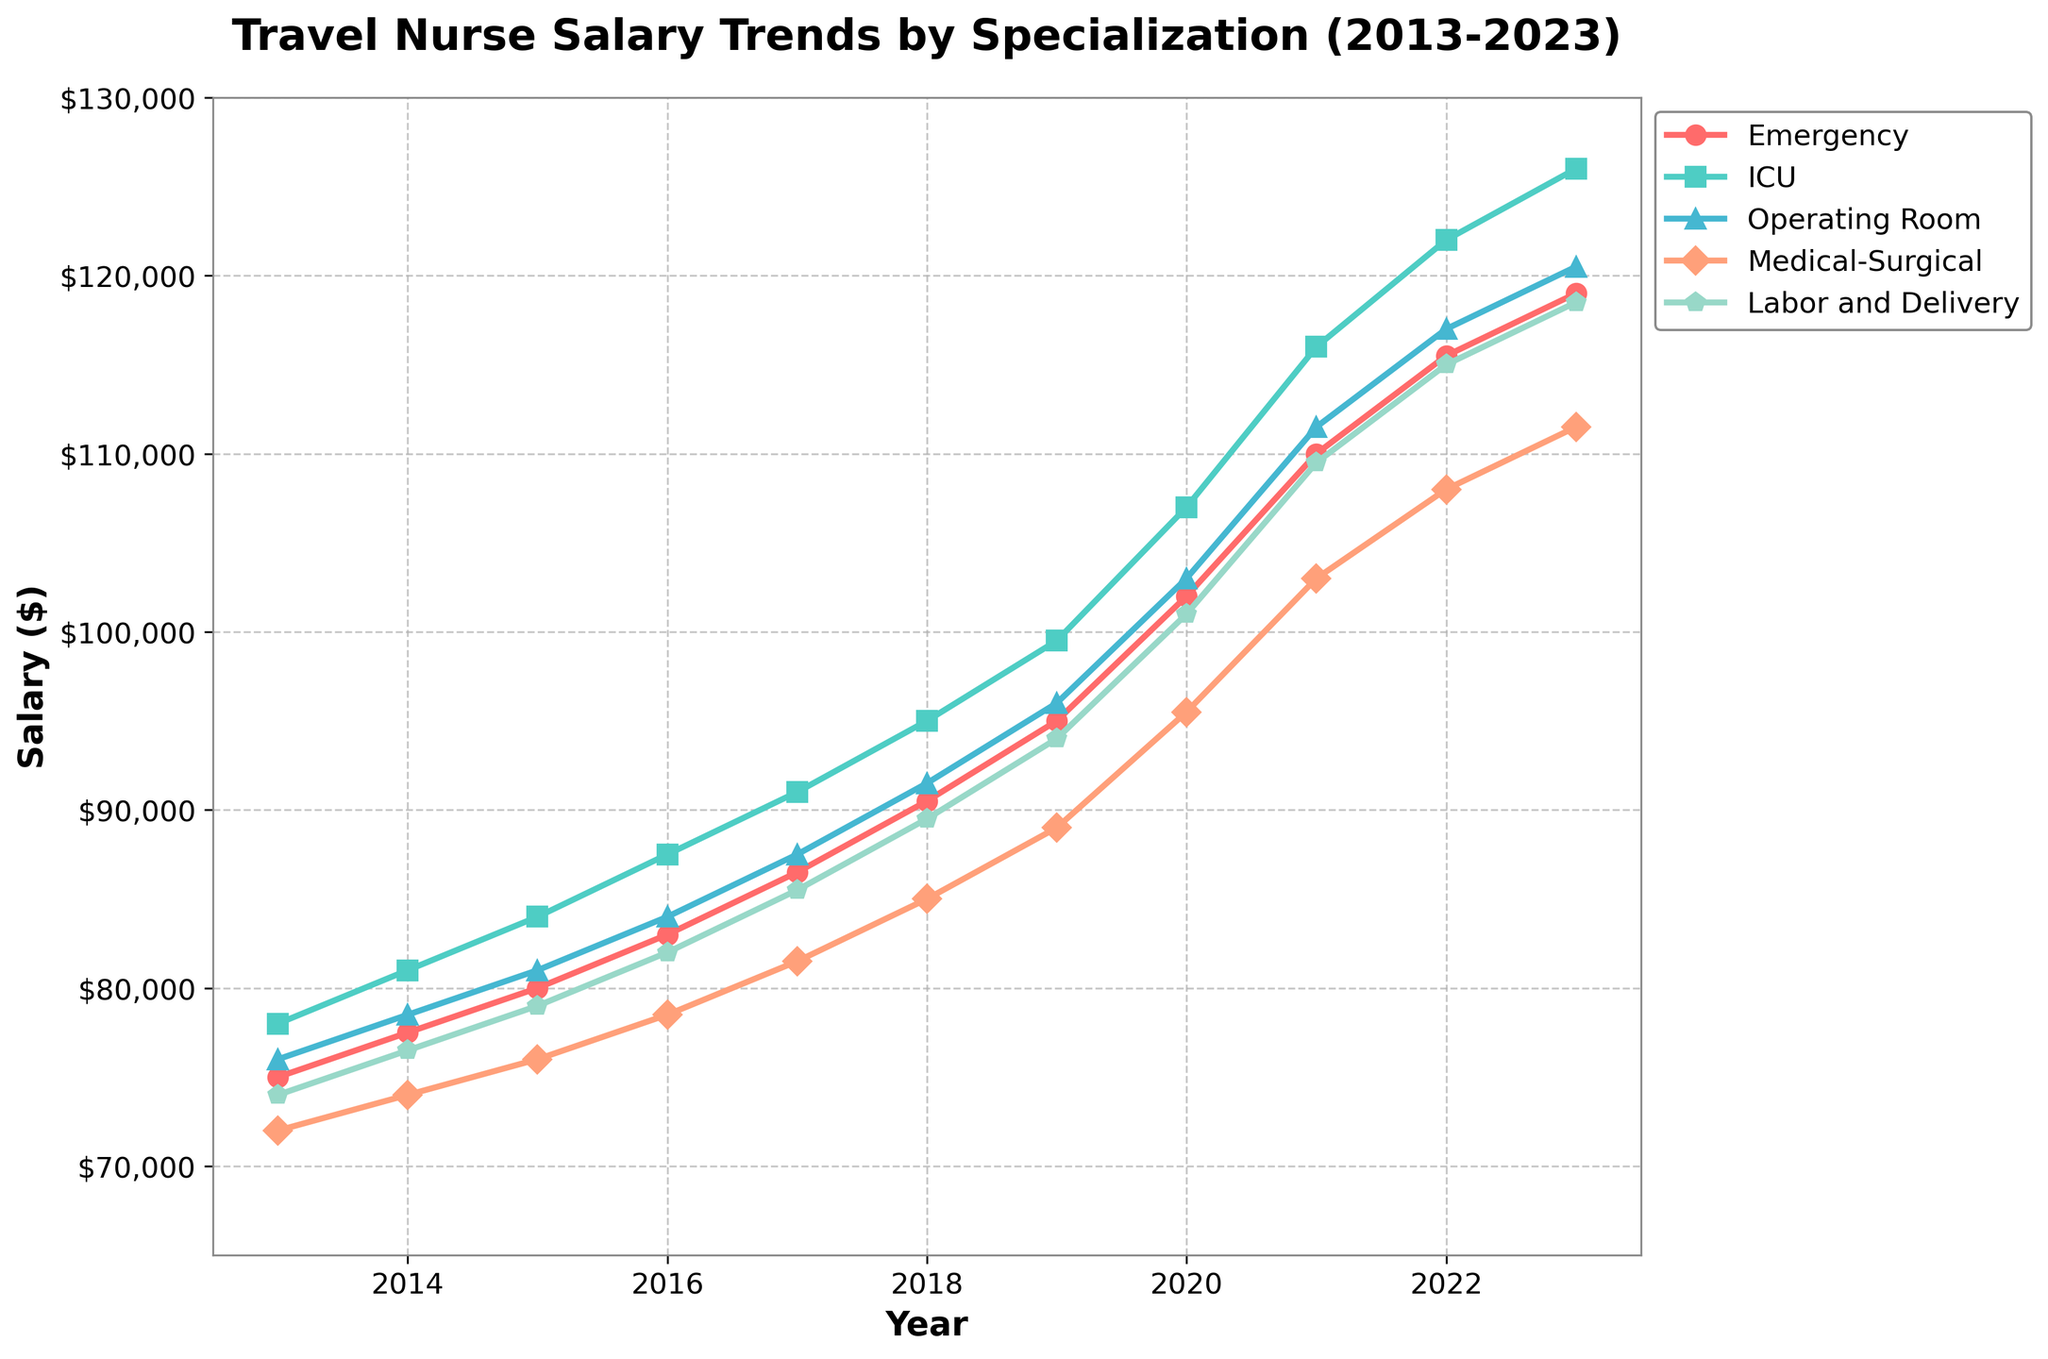Which specialization had the highest salary in 2023? By examining the endpoints of the lines in 2023, the ICU specialization shows the highest final value.
Answer: ICU Which specialization saw the largest salary increase from 2013 to 2023? To determine this, calculate the difference between salaries in 2023 and 2013 for each specialization: Emergency ($119,000 - $75,000 = $44,000), ICU ($126,000 - $78,000 = $48,000), Operating Room ($120,500 - $76,000 = $44,500), Medical-Surgical ($111,500 - $72,000 = $39,500), Labor and Delivery ($118,500 - $74,000 = $44,500). The ICU specialization had the largest increase.
Answer: ICU What is the average salary of ICU nurses in 2021 and 2022? First, sum the ICU salaries for 2021 and 2022 ($116,000 + $122,000 = $238,000), then divide by 2 to find the average ($238,000 / 2 = $119,000).
Answer: $119,000 In which year did the Emergency nurses' salary exceed $100,000 for the first time? Trace the line for the Emergency specialization across the years and find the point where it first exceeds $100,000, which occurs in 2020.
Answer: 2020 How much more did Operating Room nurses earn compared to Medical-Surgical nurses in 2023? Subtract the 2023 salary of Medical-Surgical nurses from that of Operating Room nurses ($120,500 - $111,500 = $9,000).
Answer: $9,000 Which specialization had the smallest salary increase between 2018 and 2022? Calculate the salary increase for each specialization between 2018 and 2022: Emergency ($115,500 - $90,500 = $25,000), ICU ($122,000 - $95,000 = $27,000), Operating Room ($117,000 - $91,500 = $25,500), Medical-Surgical ($108,000 - $85,000 = $23,000), Labor and Delivery ($115,000 - $89,500 = $25,500). Medical-Surgical had the smallest increase.
Answer: Medical-Surgical What was the highest salary recorded for Labor and Delivery nurses? Examine the line associated with Labor and Delivery nurses and identify the highest value point, which is $118,500 in 2023.
Answer: $118,500 Did any specialization experience a salary decrease in any year from 2013 to 2023? Inspect each line specifically looking for any downward trends. All lines show an upward trajectory, indicating no salary decrease.
Answer: No What was the approximate slope of the salary trend for ICU nurses between 2019 and 2020? Calculate the slope as the change in salary over the change in years: ($107,000 - $99,500) / (2020 - 2019) = $7,500.
Answer: $7,500 